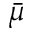<formula> <loc_0><loc_0><loc_500><loc_500>\bar { \mu }</formula> 